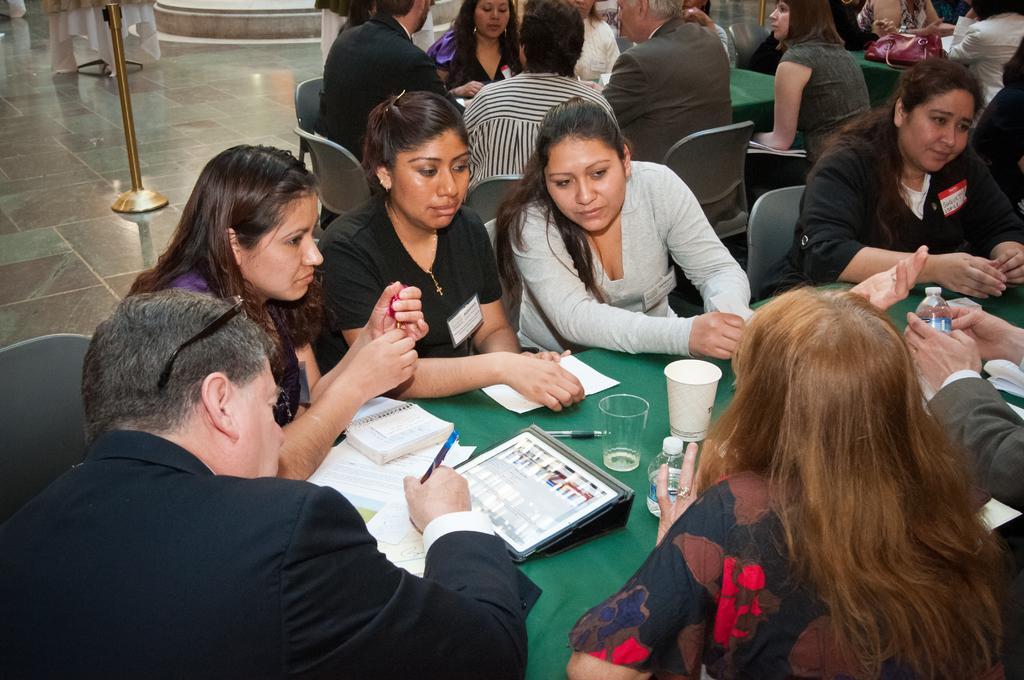Please provide a concise description of this image. In the foreground of the picture there are people, chairs, tables, glasses, papers, books, pens, bottles and other objects. On the left there is a stand. 